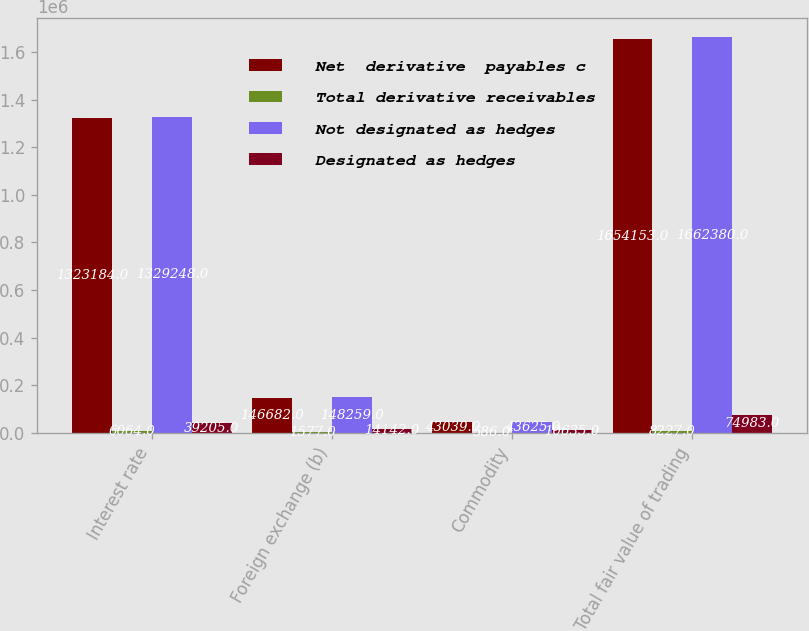Convert chart. <chart><loc_0><loc_0><loc_500><loc_500><stacked_bar_chart><ecel><fcel>Interest rate<fcel>Foreign exchange (b)<fcel>Commodity<fcel>Total fair value of trading<nl><fcel>Net  derivative  payables c<fcel>1.32318e+06<fcel>146682<fcel>43039<fcel>1.65415e+06<nl><fcel>Total derivative receivables<fcel>6064<fcel>1577<fcel>586<fcel>8227<nl><fcel>Not designated as hedges<fcel>1.32925e+06<fcel>148259<fcel>43625<fcel>1.66238e+06<nl><fcel>Designated as hedges<fcel>39205<fcel>14142<fcel>10635<fcel>74983<nl></chart> 